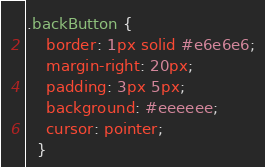Convert code to text. <code><loc_0><loc_0><loc_500><loc_500><_CSS_>
.backButton {
    border: 1px solid #e6e6e6;
    margin-right: 20px;
    padding: 3px 5px;
    background: #eeeeee;
    cursor: pointer;
  }</code> 